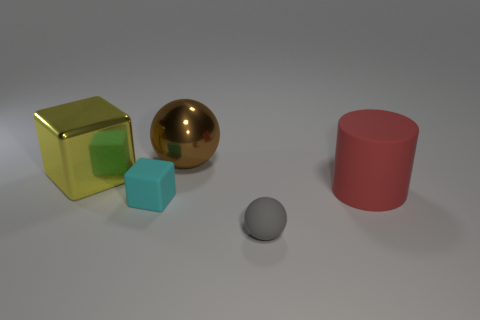How many things are brown metal spheres or gray matte spheres?
Your answer should be compact. 2. Is there any other thing that is the same shape as the big rubber object?
Your response must be concise. No. The matte thing behind the small cyan matte object in front of the large yellow cube is what shape?
Your answer should be very brief. Cylinder. There is another big thing that is the same material as the gray object; what is its shape?
Your response must be concise. Cylinder. What is the size of the sphere that is in front of the ball that is behind the red rubber cylinder?
Ensure brevity in your answer.  Small. The gray thing has what shape?
Ensure brevity in your answer.  Sphere. What number of tiny things are cyan matte things or yellow things?
Keep it short and to the point. 1. There is a yellow object that is the same shape as the cyan matte object; what size is it?
Offer a very short reply. Large. What number of tiny things are to the left of the tiny rubber sphere and right of the brown metallic ball?
Offer a terse response. 0. Does the red object have the same shape as the shiny thing that is to the right of the cyan rubber object?
Make the answer very short. No. 